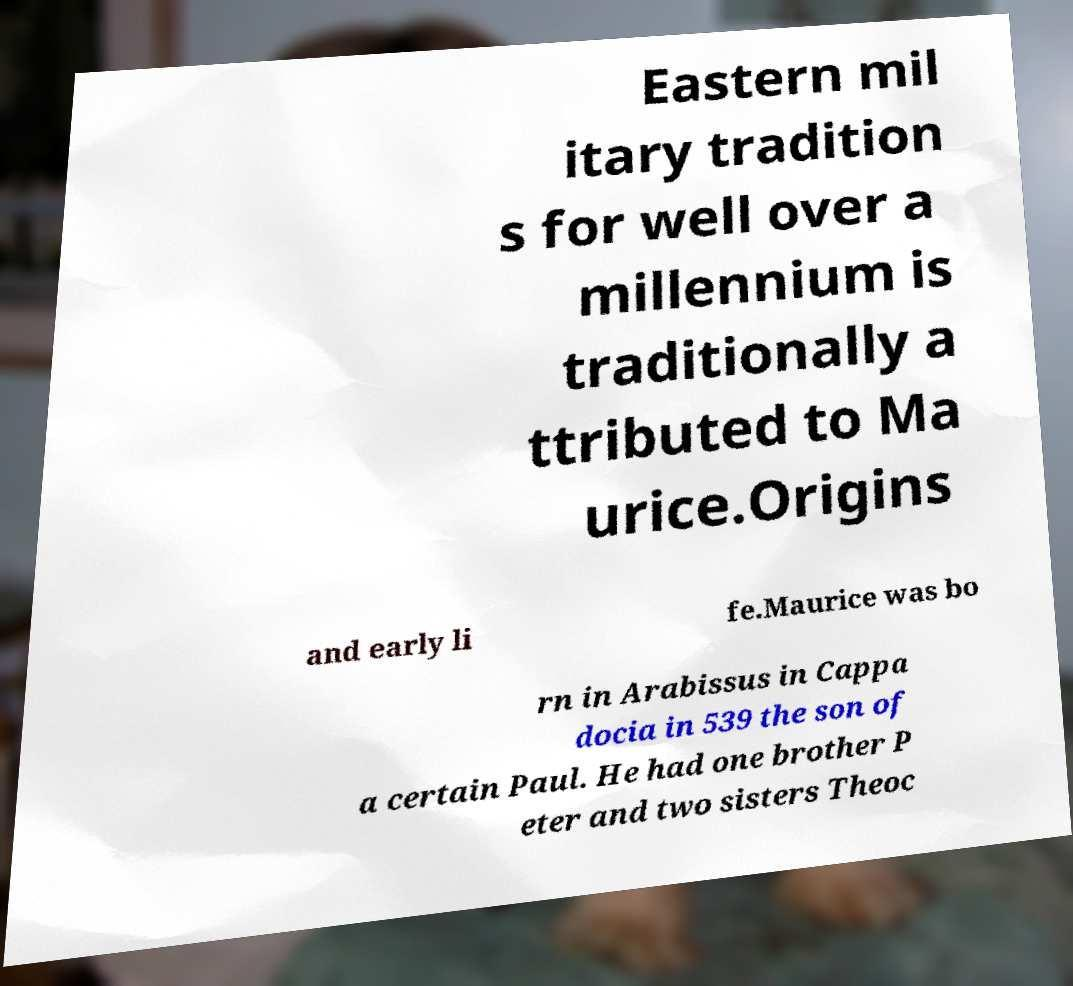Can you accurately transcribe the text from the provided image for me? Eastern mil itary tradition s for well over a millennium is traditionally a ttributed to Ma urice.Origins and early li fe.Maurice was bo rn in Arabissus in Cappa docia in 539 the son of a certain Paul. He had one brother P eter and two sisters Theoc 